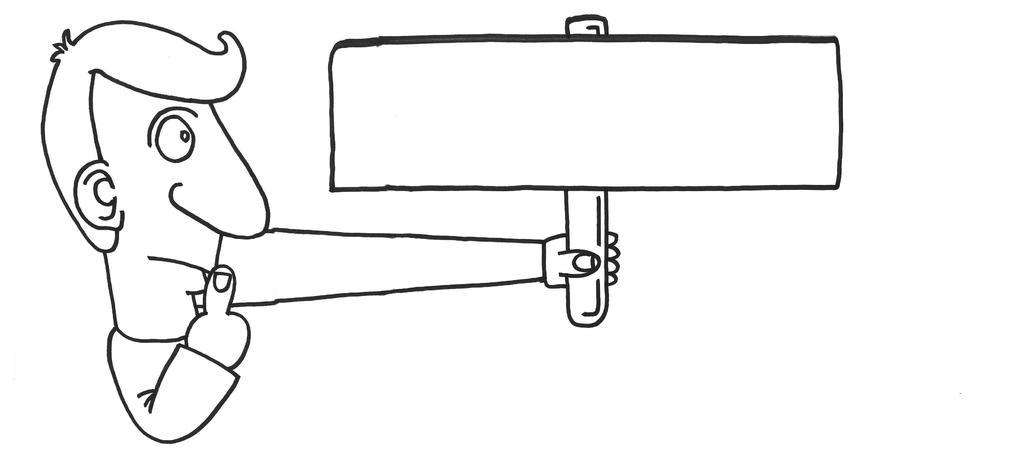Can you describe this image briefly? In this image, we can see a sketch of a cartoon, holding an object. 